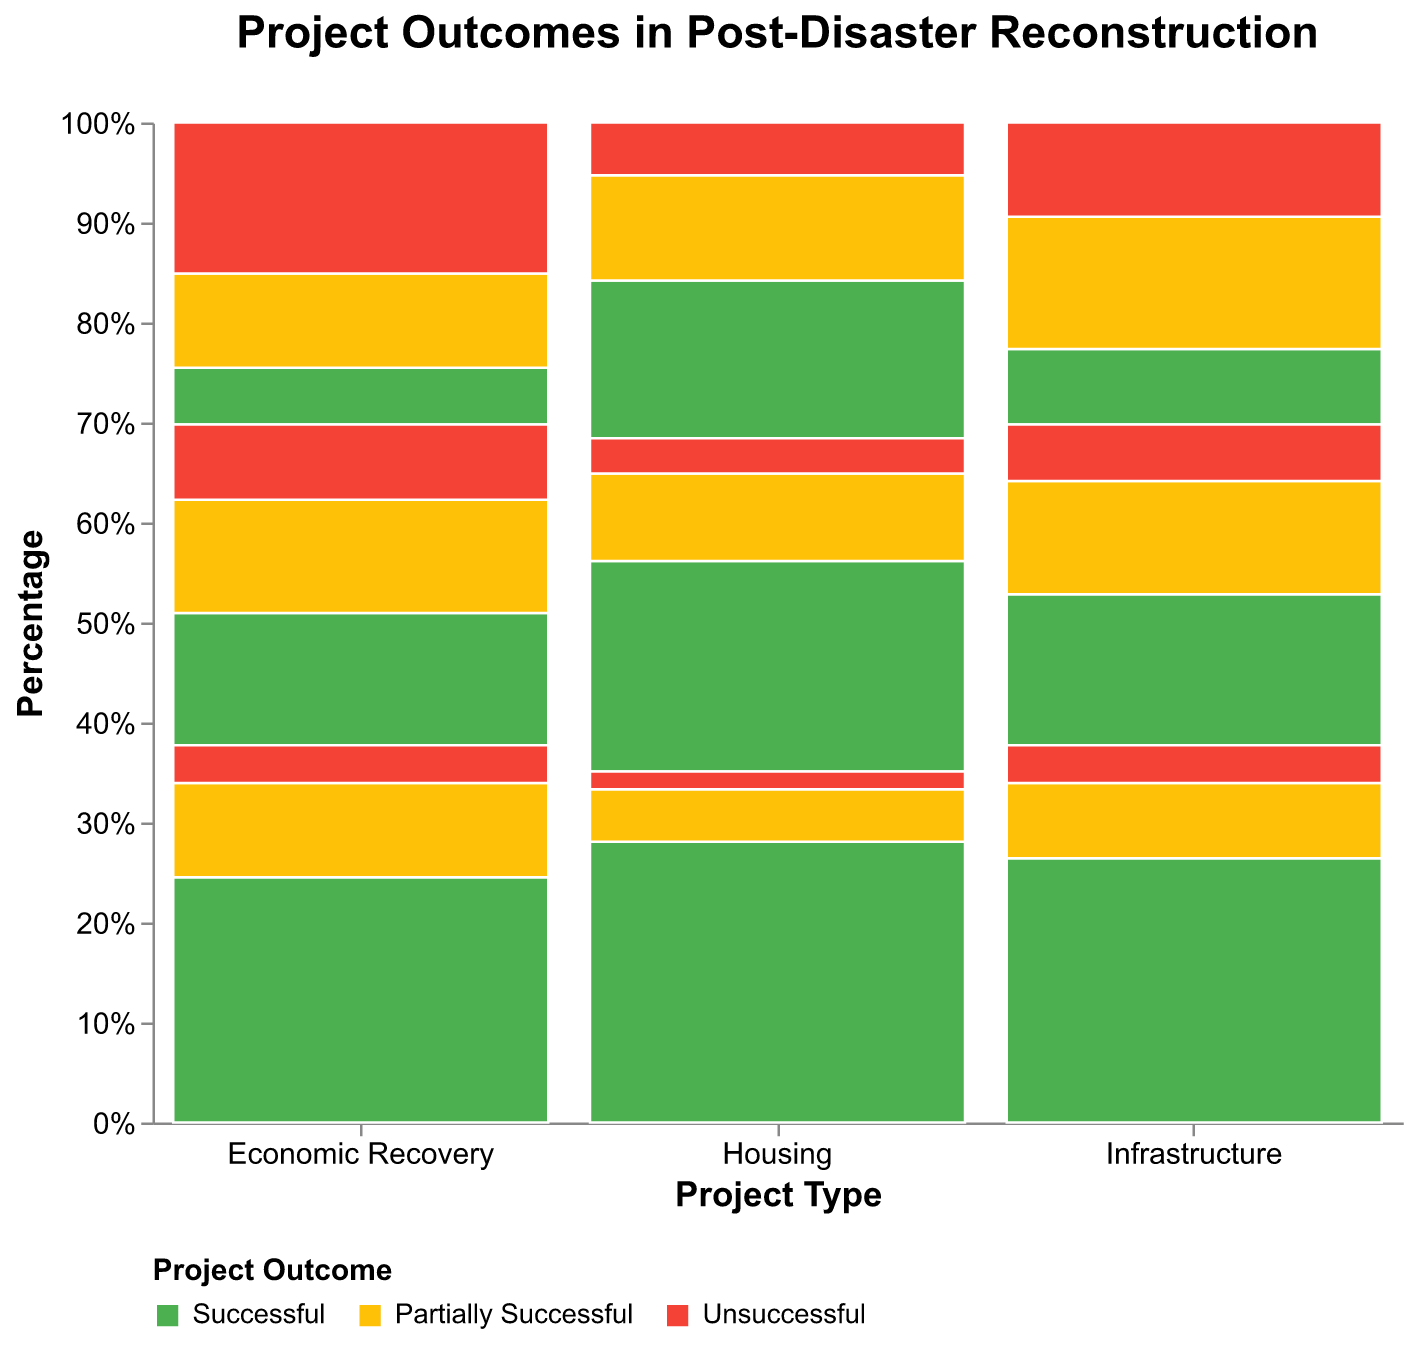What is the proportion of successful Housing projects in the long-term timeline? To find the proportion of successful Housing projects in the long-term timeline, locate the 'Housing' category on the x-axis and the 'Long-term' section. Identify the 'Successful' outcome segment. Based on the plot, the segment size indicates 80 successful projects out of a total of 100 (80 + 15 + 5). Therefore, the proportion is 80%.
Answer: 80% Which project type has the highest proportion of unsuccessful outcomes in the short-term timeline? Compare the size of 'Unsuccessful' outcome segments for each project type within the 'Short-term' timeline. The 'Economic Recovery' project type has the largest proportion, indicated by 40 unsuccessful projects out of a total of 80 (15 + 25 + 40).
Answer: Economic Recovery How does the proportion of partially successful projects change from short-term to long-term for Infrastructure projects? Observe the 'Infrastructure' category and compare the sizes of 'Partially Successful' outcome segments across timelines. In the 'Short-term', it's 35 out of 80 (20 + 35 + 25), in 'Medium-term', it's 30 out of 85 (40 + 30 + 15), and in 'Long-term', it's 20 out of 100 (70 + 20 + 10). Thus, the proportion decreases over time from 43.75% (short-term) to 35.29% (medium-term), and then to 20% (long-term).
Answer: Decreases What can we infer about the success rates of Housing projects based on the timeline? Examine the 'Housing' category by looking at the 'Successful' outcome proportion across different timelines. In 'Short-term', the proportion is 45 out of 90 (45 + 30 + 15), in 'Medium-term', it's 60 out of 95 (60 + 25 + 10), and in 'Long-term', it's 80 out of 100 (80 + 15 + 5). The success rate increases over time from 50% (short-term) to ~63.16% (medium-term) to 80% (long-term).
Answer: Increases What is the total number of partially successful projects across all project types and timelines? Add the counts of 'Partially Successful' projects across all categories and timelines. For Housing: 30 + 25 + 15 = 70, Infrastructure: 35 + 30 + 20 = 85, and Economic Recovery: 25 + 30 + 25 = 80. Summing these values gives 70 + 85 + 80 = 235.
Answer: 235 